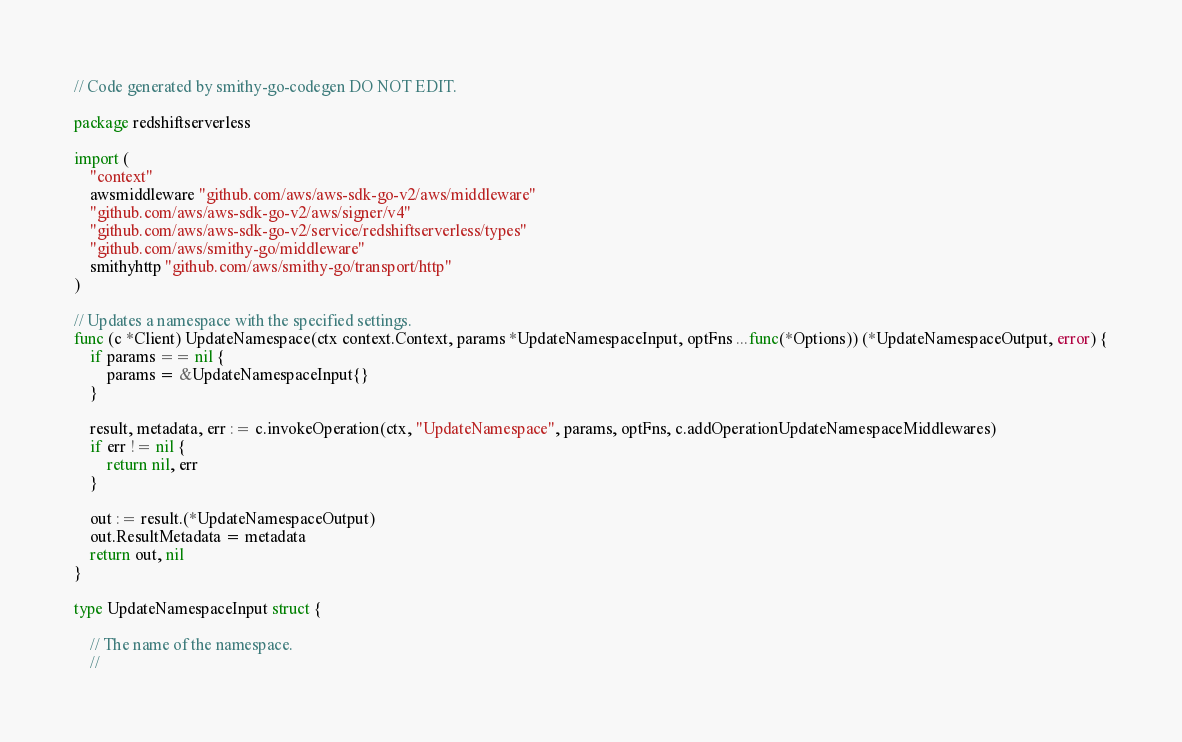Convert code to text. <code><loc_0><loc_0><loc_500><loc_500><_Go_>// Code generated by smithy-go-codegen DO NOT EDIT.

package redshiftserverless

import (
	"context"
	awsmiddleware "github.com/aws/aws-sdk-go-v2/aws/middleware"
	"github.com/aws/aws-sdk-go-v2/aws/signer/v4"
	"github.com/aws/aws-sdk-go-v2/service/redshiftserverless/types"
	"github.com/aws/smithy-go/middleware"
	smithyhttp "github.com/aws/smithy-go/transport/http"
)

// Updates a namespace with the specified settings.
func (c *Client) UpdateNamespace(ctx context.Context, params *UpdateNamespaceInput, optFns ...func(*Options)) (*UpdateNamespaceOutput, error) {
	if params == nil {
		params = &UpdateNamespaceInput{}
	}

	result, metadata, err := c.invokeOperation(ctx, "UpdateNamespace", params, optFns, c.addOperationUpdateNamespaceMiddlewares)
	if err != nil {
		return nil, err
	}

	out := result.(*UpdateNamespaceOutput)
	out.ResultMetadata = metadata
	return out, nil
}

type UpdateNamespaceInput struct {

	// The name of the namespace.
	//</code> 